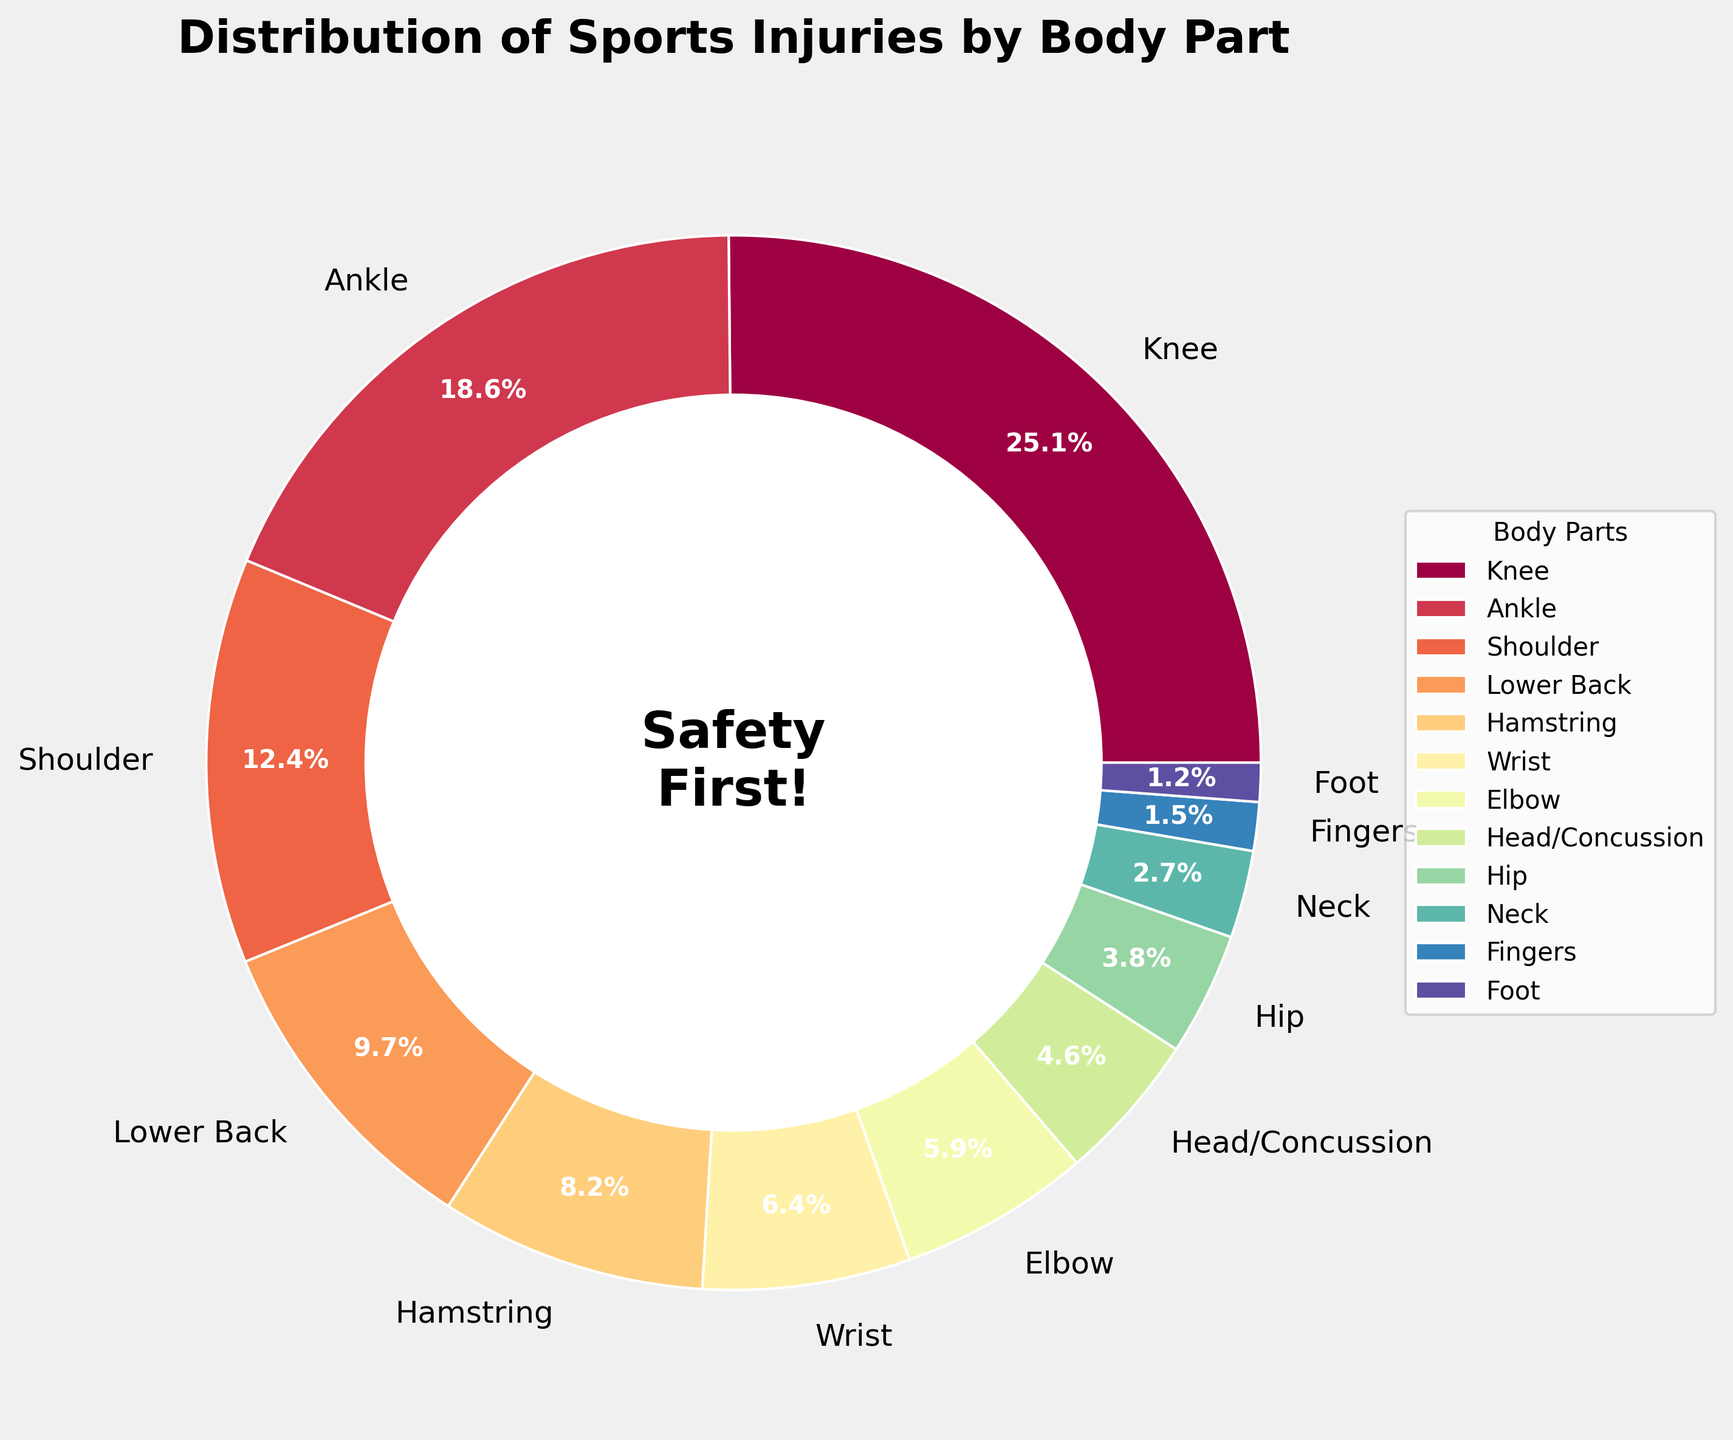What's the most common body part injured? The pie chart shows the percentage distribution of sports injuries by body part, and the largest segment represents knee injuries at 25.3%.
Answer: Knee Which injury is more common, ankle or shoulder? To determine which injury is more common, compare the percentages for ankle (18.7%) and shoulder (12.5%). Ankle injuries have a higher percentage.
Answer: Ankle What's the combined percentage of knee and ankle injuries? The pie chart shows that knee injuries are 25.3% and ankle injuries are 18.7%. By adding these two percentages, we get 25.3% + 18.7% = 44%.
Answer: 44% Are lower back injuries more or less frequent than hamstring injuries? According to the pie chart, lower back injuries are 9.8% and hamstring injuries are 8.2%. Since 9.8% is greater than 8.2%, lower back injuries are more frequent.
Answer: More What is the total percentage of injuries to the upper body (shoulder, wrist, elbow, head/concussion, neck)? Sum the percentages of shoulder (12.5%), wrist (6.4%), elbow (5.9%), head/concussion (4.6%), and neck (2.7%): 12.5% + 6.4% + 5.9% + 4.6% + 2.7% = 32.1%.
Answer: 32.1% Which injury has a percentage closest to 5%? Inspect the chart for injuries around 5%. The elbow has a percentage of 5.9%, which is the closest to 5%.
Answer: Elbow Is the percentage of knee injuries greater than the sum of wrist and foot injuries? Knee injuries are 25.3%. Wrist injuries are 6.4% and foot injuries are 1.2%; their sum is 6.4% + 1.2% = 7.6%. Since 25.3% is greater than 7.6%, knee injuries percentage is greater.
Answer: Yes What is the least common injury? Identify the smallest segment in the pie chart. The foot has the smallest percentage at 1.2%.
Answer: Foot What's the difference in percentage between the most and least common injuries? The most common injury is knee (25.3%), and the least common is foot (1.2%). The difference is 25.3% - 1.2% = 24.1%.
Answer: 24.1% What fraction of injuries are head/concussions? Head/concussions are 4.6%. To convert this to a fraction, 4.6% is equivalent to 4.6/100, which simplifies to 23/500 when simplified.
Answer: 23/500 